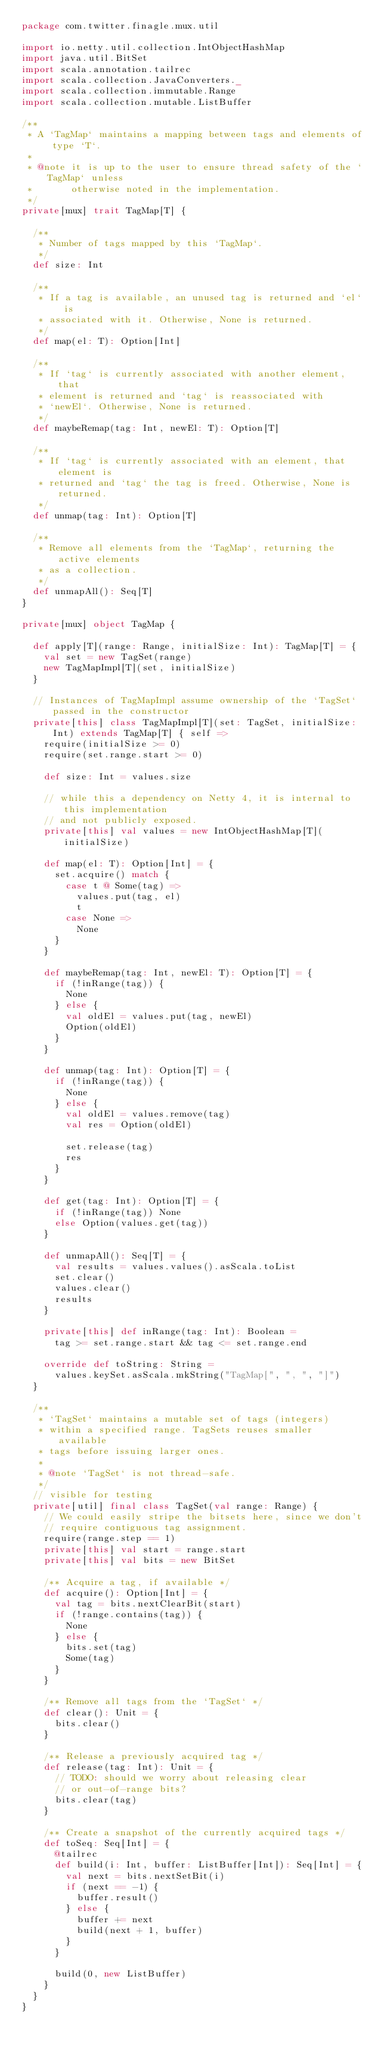Convert code to text. <code><loc_0><loc_0><loc_500><loc_500><_Scala_>package com.twitter.finagle.mux.util

import io.netty.util.collection.IntObjectHashMap
import java.util.BitSet
import scala.annotation.tailrec
import scala.collection.JavaConverters._
import scala.collection.immutable.Range
import scala.collection.mutable.ListBuffer

/**
 * A `TagMap` maintains a mapping between tags and elements of type `T`.
 *
 * @note it is up to the user to ensure thread safety of the `TagMap` unless
 *       otherwise noted in the implementation.
 */
private[mux] trait TagMap[T] {

  /**
   * Number of tags mapped by this `TagMap`.
   */
  def size: Int

  /**
   * If a tag is available, an unused tag is returned and `el` is
   * associated with it. Otherwise, None is returned.
   */
  def map(el: T): Option[Int]

  /**
   * If `tag` is currently associated with another element, that
   * element is returned and `tag` is reassociated with
   * `newEl`. Otherwise, None is returned.
   */
  def maybeRemap(tag: Int, newEl: T): Option[T]

  /**
   * If `tag` is currently associated with an element, that element is
   * returned and `tag` the tag is freed. Otherwise, None is returned.
   */
  def unmap(tag: Int): Option[T]

  /**
   * Remove all elements from the `TagMap`, returning the active elements
   * as a collection.
   */
  def unmapAll(): Seq[T]
}

private[mux] object TagMap {

  def apply[T](range: Range, initialSize: Int): TagMap[T] = {
    val set = new TagSet(range)
    new TagMapImpl[T](set, initialSize)
  }

  // Instances of TagMapImpl assume ownership of the `TagSet` passed in the constructor
  private[this] class TagMapImpl[T](set: TagSet, initialSize: Int) extends TagMap[T] { self =>
    require(initialSize >= 0)
    require(set.range.start >= 0)

    def size: Int = values.size

    // while this a dependency on Netty 4, it is internal to this implementation
    // and not publicly exposed.
    private[this] val values = new IntObjectHashMap[T](initialSize)

    def map(el: T): Option[Int] = {
      set.acquire() match {
        case t @ Some(tag) =>
          values.put(tag, el)
          t
        case None =>
          None
      }
    }

    def maybeRemap(tag: Int, newEl: T): Option[T] = {
      if (!inRange(tag)) {
        None
      } else {
        val oldEl = values.put(tag, newEl)
        Option(oldEl)
      }
    }

    def unmap(tag: Int): Option[T] = {
      if (!inRange(tag)) {
        None
      } else {
        val oldEl = values.remove(tag)
        val res = Option(oldEl)

        set.release(tag)
        res
      }
    }

    def get(tag: Int): Option[T] = {
      if (!inRange(tag)) None
      else Option(values.get(tag))
    }

    def unmapAll(): Seq[T] = {
      val results = values.values().asScala.toList
      set.clear()
      values.clear()
      results
    }

    private[this] def inRange(tag: Int): Boolean =
      tag >= set.range.start && tag <= set.range.end

    override def toString: String =
      values.keySet.asScala.mkString("TagMap[", ", ", "]")
  }

  /**
   * `TagSet` maintains a mutable set of tags (integers)
   * within a specified range. TagSets reuses smaller available
   * tags before issuing larger ones.
   *
   * @note `TagSet` is not thread-safe.
   */
  // visible for testing
  private[util] final class TagSet(val range: Range) {
    // We could easily stripe the bitsets here, since we don't
    // require contiguous tag assignment.
    require(range.step == 1)
    private[this] val start = range.start
    private[this] val bits = new BitSet

    /** Acquire a tag, if available */
    def acquire(): Option[Int] = {
      val tag = bits.nextClearBit(start)
      if (!range.contains(tag)) {
        None
      } else {
        bits.set(tag)
        Some(tag)
      }
    }

    /** Remove all tags from the `TagSet` */
    def clear(): Unit = {
      bits.clear()
    }

    /** Release a previously acquired tag */
    def release(tag: Int): Unit = {
      // TODO: should we worry about releasing clear
      // or out-of-range bits?
      bits.clear(tag)
    }

    /** Create a snapshot of the currently acquired tags */
    def toSeq: Seq[Int] = {
      @tailrec
      def build(i: Int, buffer: ListBuffer[Int]): Seq[Int] = {
        val next = bits.nextSetBit(i)
        if (next == -1) {
          buffer.result()
        } else {
          buffer += next
          build(next + 1, buffer)
        }
      }

      build(0, new ListBuffer)
    }
  }
}
</code> 